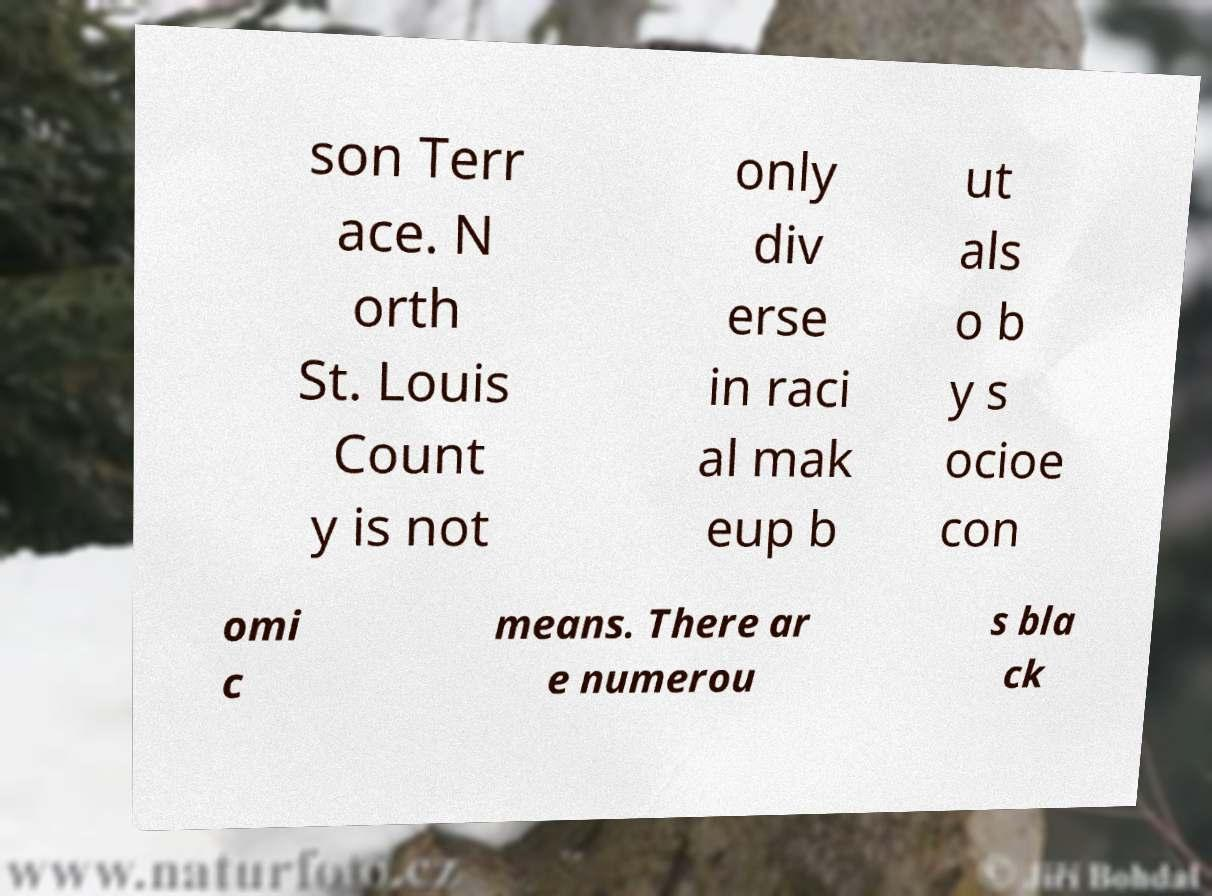What messages or text are displayed in this image? I need them in a readable, typed format. son Terr ace. N orth St. Louis Count y is not only div erse in raci al mak eup b ut als o b y s ocioe con omi c means. There ar e numerou s bla ck 